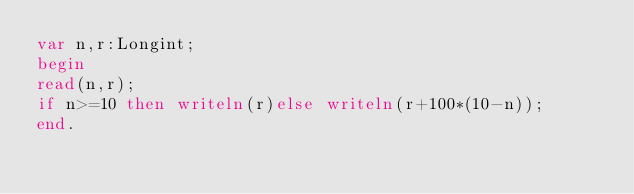Convert code to text. <code><loc_0><loc_0><loc_500><loc_500><_Pascal_>var n,r:Longint;
begin
read(n,r);
if n>=10 then writeln(r)else writeln(r+100*(10-n));
end.</code> 